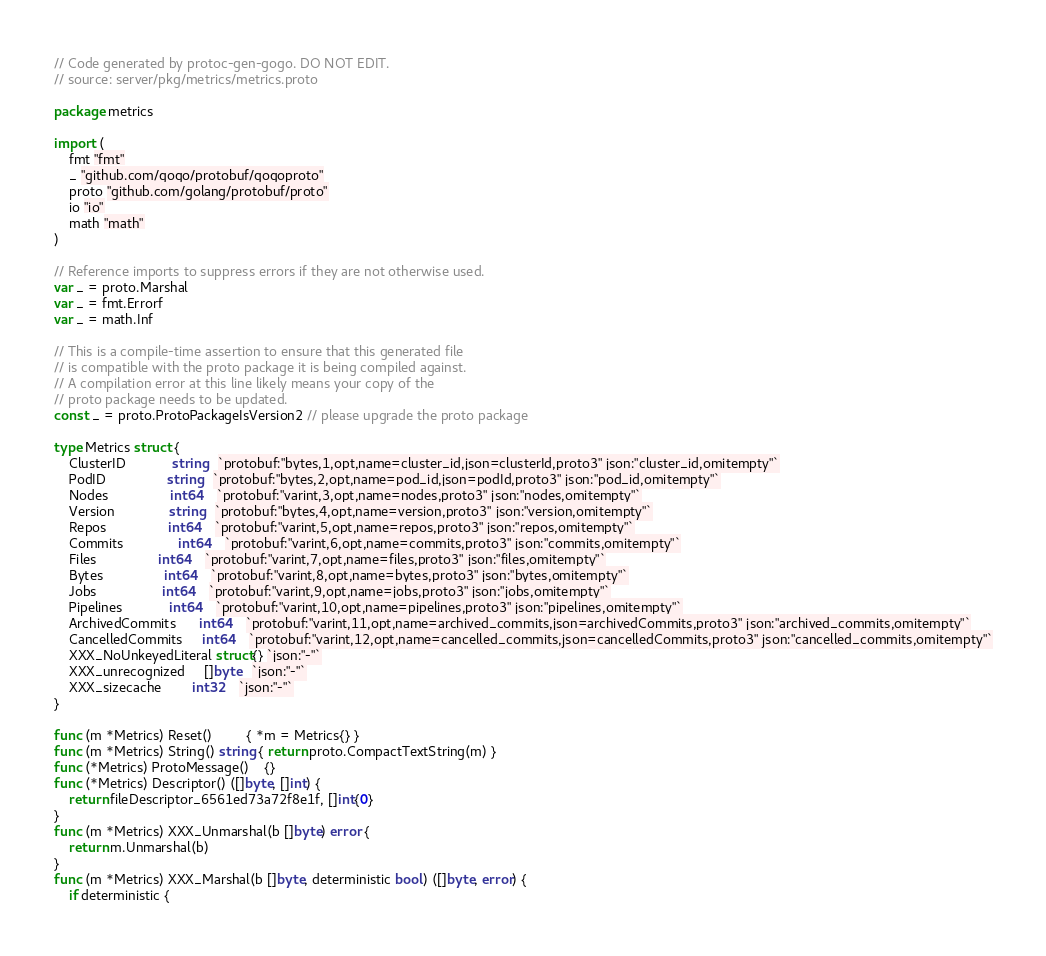Convert code to text. <code><loc_0><loc_0><loc_500><loc_500><_Go_>// Code generated by protoc-gen-gogo. DO NOT EDIT.
// source: server/pkg/metrics/metrics.proto

package metrics

import (
	fmt "fmt"
	_ "github.com/gogo/protobuf/gogoproto"
	proto "github.com/golang/protobuf/proto"
	io "io"
	math "math"
)

// Reference imports to suppress errors if they are not otherwise used.
var _ = proto.Marshal
var _ = fmt.Errorf
var _ = math.Inf

// This is a compile-time assertion to ensure that this generated file
// is compatible with the proto package it is being compiled against.
// A compilation error at this line likely means your copy of the
// proto package needs to be updated.
const _ = proto.ProtoPackageIsVersion2 // please upgrade the proto package

type Metrics struct {
	ClusterID            string   `protobuf:"bytes,1,opt,name=cluster_id,json=clusterId,proto3" json:"cluster_id,omitempty"`
	PodID                string   `protobuf:"bytes,2,opt,name=pod_id,json=podId,proto3" json:"pod_id,omitempty"`
	Nodes                int64    `protobuf:"varint,3,opt,name=nodes,proto3" json:"nodes,omitempty"`
	Version              string   `protobuf:"bytes,4,opt,name=version,proto3" json:"version,omitempty"`
	Repos                int64    `protobuf:"varint,5,opt,name=repos,proto3" json:"repos,omitempty"`
	Commits              int64    `protobuf:"varint,6,opt,name=commits,proto3" json:"commits,omitempty"`
	Files                int64    `protobuf:"varint,7,opt,name=files,proto3" json:"files,omitempty"`
	Bytes                int64    `protobuf:"varint,8,opt,name=bytes,proto3" json:"bytes,omitempty"`
	Jobs                 int64    `protobuf:"varint,9,opt,name=jobs,proto3" json:"jobs,omitempty"`
	Pipelines            int64    `protobuf:"varint,10,opt,name=pipelines,proto3" json:"pipelines,omitempty"`
	ArchivedCommits      int64    `protobuf:"varint,11,opt,name=archived_commits,json=archivedCommits,proto3" json:"archived_commits,omitempty"`
	CancelledCommits     int64    `protobuf:"varint,12,opt,name=cancelled_commits,json=cancelledCommits,proto3" json:"cancelled_commits,omitempty"`
	XXX_NoUnkeyedLiteral struct{} `json:"-"`
	XXX_unrecognized     []byte   `json:"-"`
	XXX_sizecache        int32    `json:"-"`
}

func (m *Metrics) Reset()         { *m = Metrics{} }
func (m *Metrics) String() string { return proto.CompactTextString(m) }
func (*Metrics) ProtoMessage()    {}
func (*Metrics) Descriptor() ([]byte, []int) {
	return fileDescriptor_6561ed73a72f8e1f, []int{0}
}
func (m *Metrics) XXX_Unmarshal(b []byte) error {
	return m.Unmarshal(b)
}
func (m *Metrics) XXX_Marshal(b []byte, deterministic bool) ([]byte, error) {
	if deterministic {</code> 